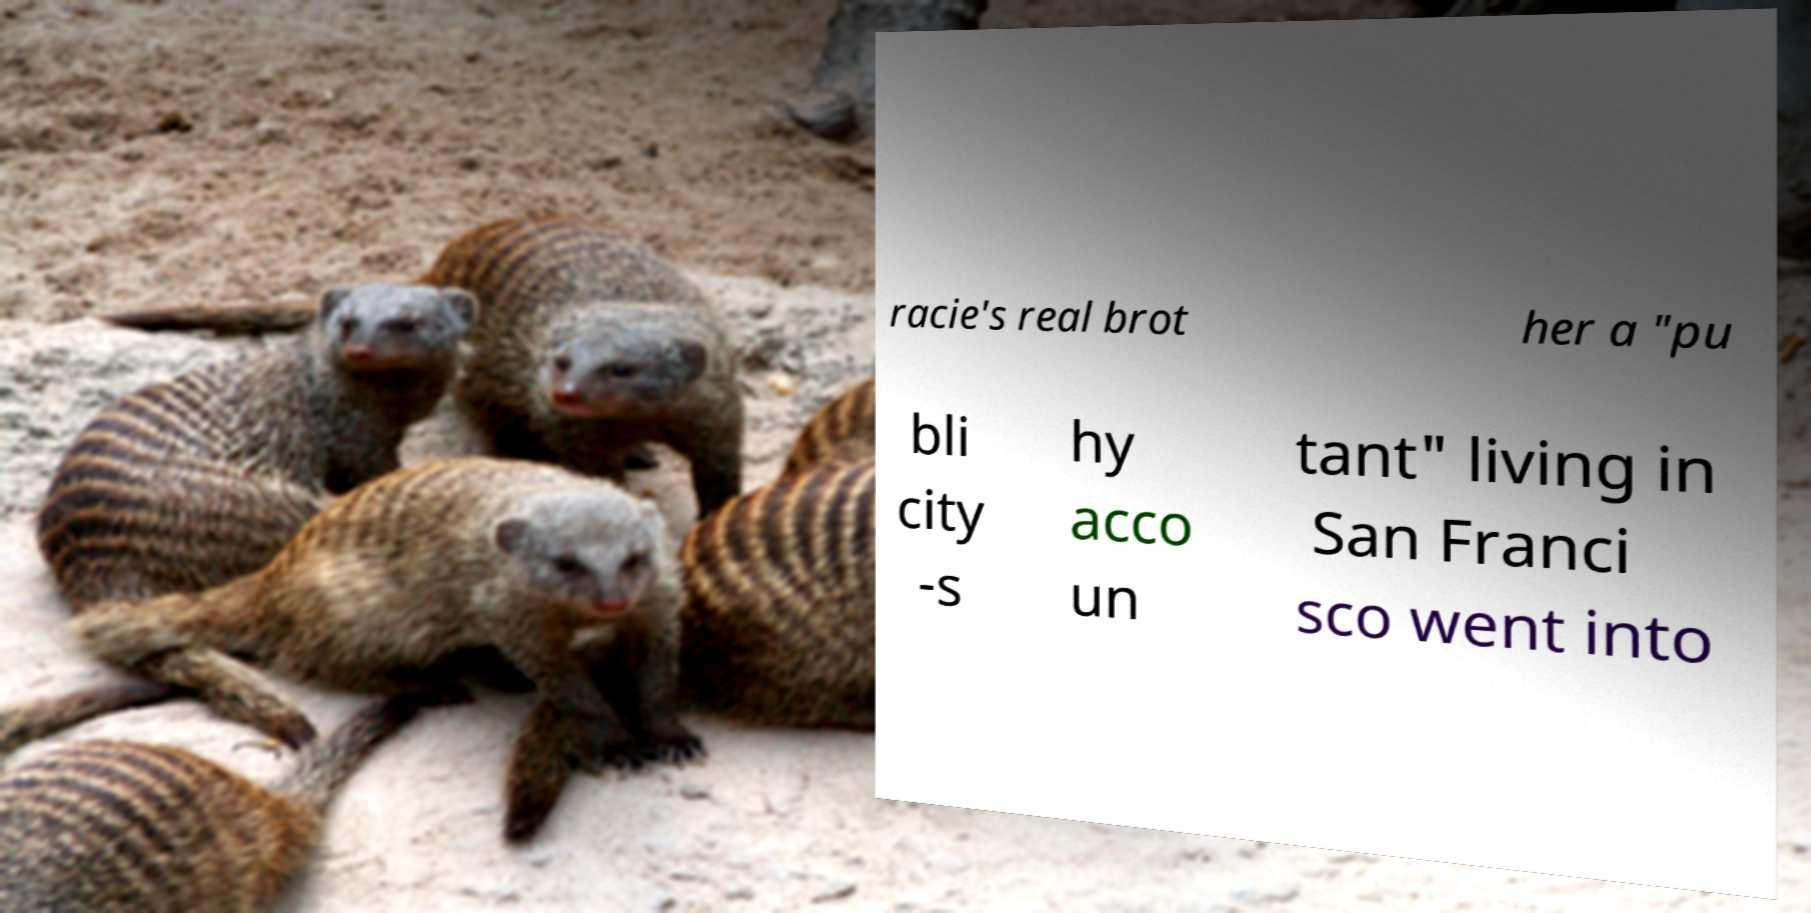I need the written content from this picture converted into text. Can you do that? racie's real brot her a "pu bli city -s hy acco un tant" living in San Franci sco went into 